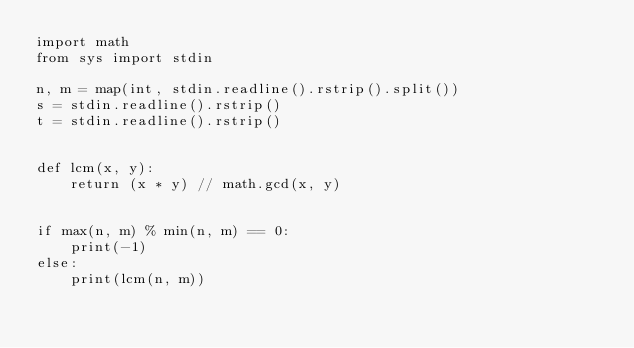<code> <loc_0><loc_0><loc_500><loc_500><_Python_>import math
from sys import stdin

n, m = map(int, stdin.readline().rstrip().split())
s = stdin.readline().rstrip()
t = stdin.readline().rstrip()


def lcm(x, y):
    return (x * y) // math.gcd(x, y)


if max(n, m) % min(n, m) == 0:
    print(-1)
else:
    print(lcm(n, m))</code> 